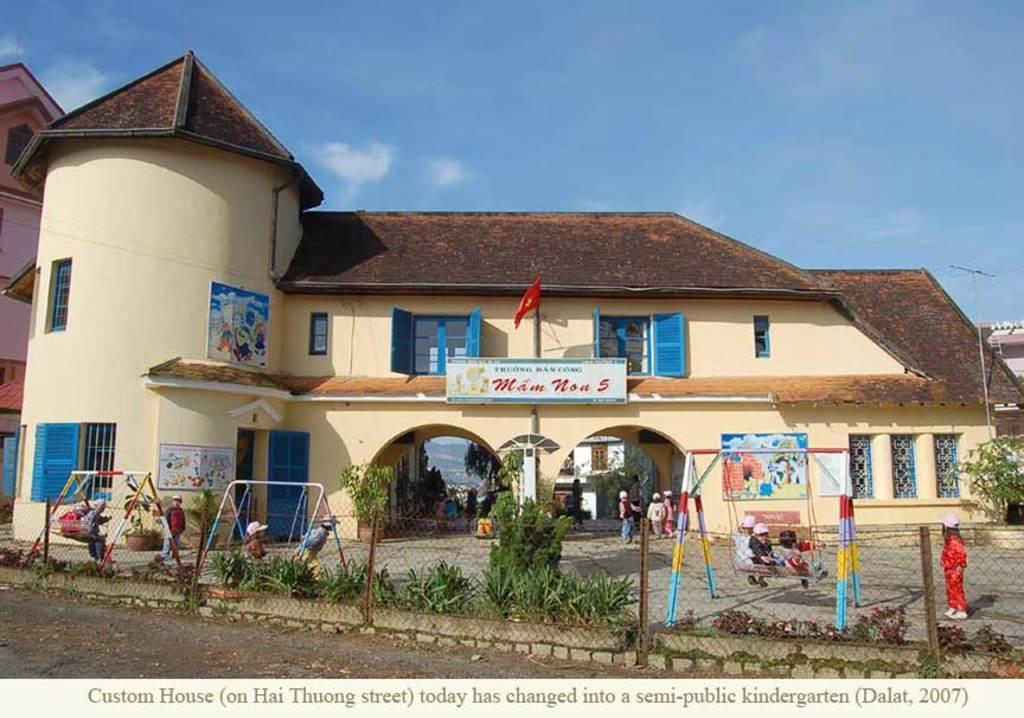Describe this image in one or two sentences. In this picture we can see the road, plants, fence, some people on swings and some people on the ground, arch, buildings, posters, flag, trees, name board and some objects and in the background we can see the sky. 